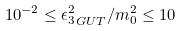Convert formula to latex. <formula><loc_0><loc_0><loc_500><loc_500>1 0 ^ { - 2 } \leq { \epsilon ^ { 2 } _ { 3 } } _ { G U T } / m _ { 0 } ^ { 2 } \leq 1 0</formula> 